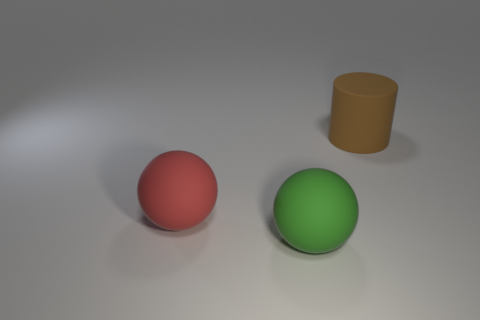Add 3 green rubber cylinders. How many objects exist? 6 Subtract all red balls. How many balls are left? 1 Subtract all balls. How many objects are left? 1 Subtract 1 cylinders. How many cylinders are left? 0 Subtract all large matte balls. Subtract all big brown rubber cubes. How many objects are left? 1 Add 2 green objects. How many green objects are left? 3 Add 1 large green things. How many large green things exist? 2 Subtract 0 gray cylinders. How many objects are left? 3 Subtract all green balls. Subtract all yellow cylinders. How many balls are left? 1 Subtract all purple cylinders. How many yellow balls are left? 0 